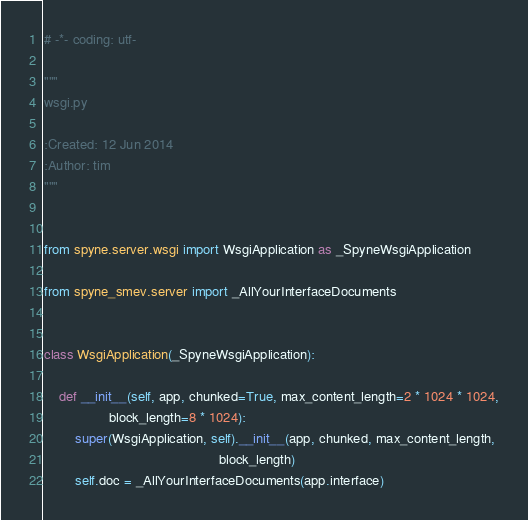<code> <loc_0><loc_0><loc_500><loc_500><_Python_># -*- coding: utf-

"""               
wsgi.py
                  
:Created: 12 Jun 2014  
:Author: tim    
"""


from spyne.server.wsgi import WsgiApplication as _SpyneWsgiApplication

from spyne_smev.server import _AllYourInterfaceDocuments


class WsgiApplication(_SpyneWsgiApplication):

    def __init__(self, app, chunked=True, max_content_length=2 * 1024 * 1024,
                 block_length=8 * 1024):
        super(WsgiApplication, self).__init__(app, chunked, max_content_length,
                                              block_length)
        self.doc = _AllYourInterfaceDocuments(app.interface)
</code> 